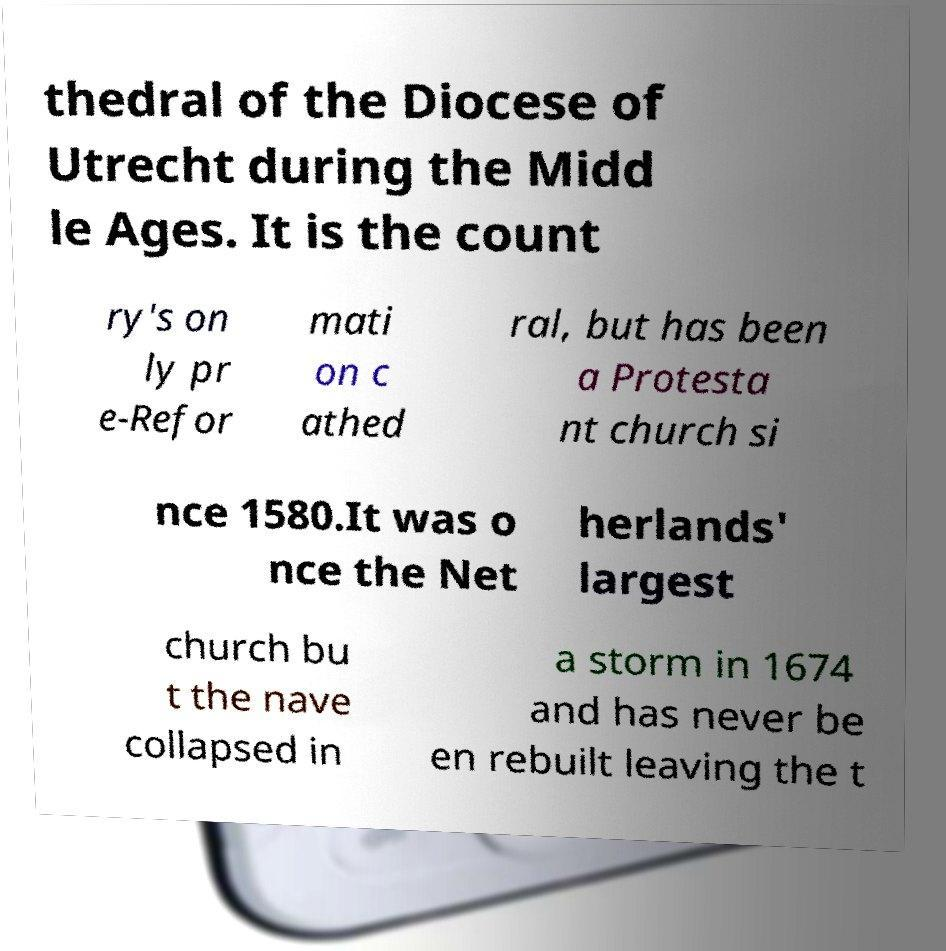There's text embedded in this image that I need extracted. Can you transcribe it verbatim? thedral of the Diocese of Utrecht during the Midd le Ages. It is the count ry's on ly pr e-Refor mati on c athed ral, but has been a Protesta nt church si nce 1580.It was o nce the Net herlands' largest church bu t the nave collapsed in a storm in 1674 and has never be en rebuilt leaving the t 